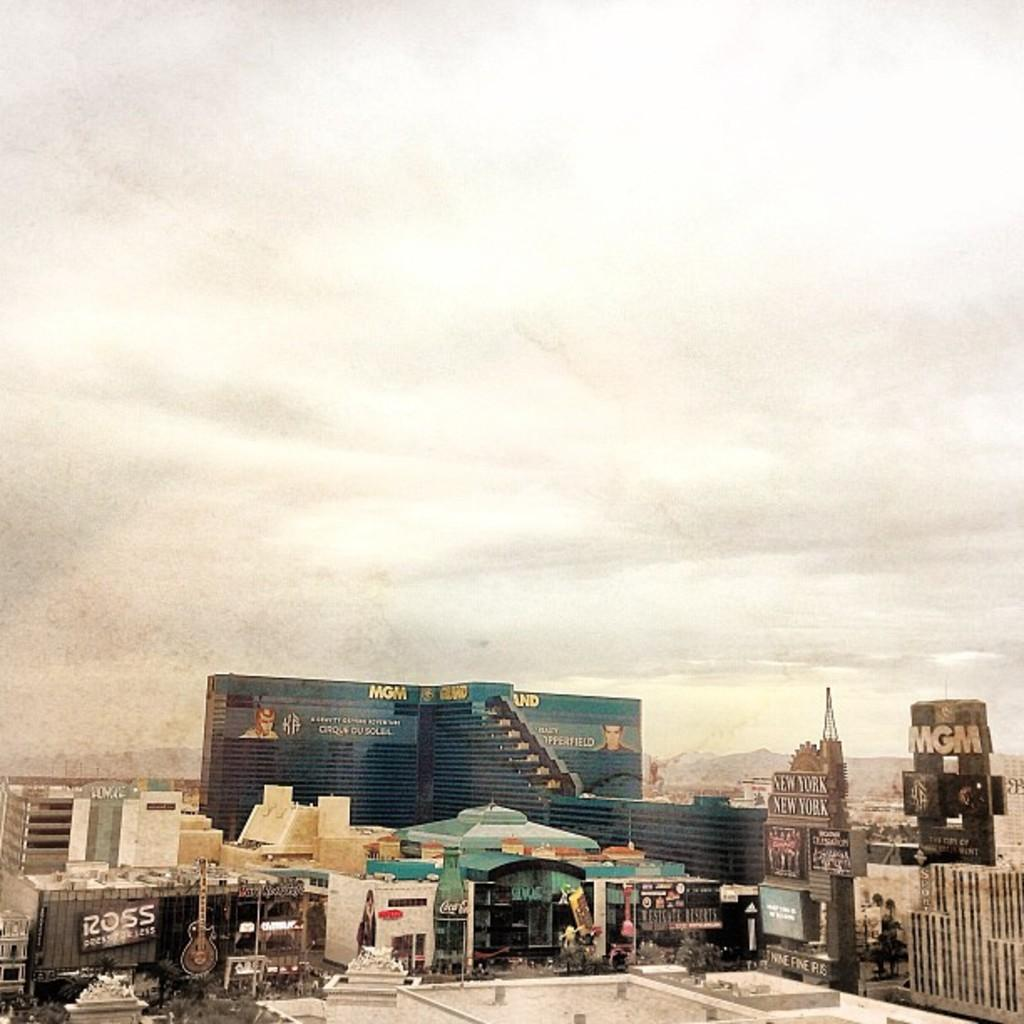What type of structures can be seen in the image? There are buildings in the image. Are there any signs or advertisements visible on the buildings or nearby? Yes, there are hoardings with text in the image. Is there any text directly on the buildings? Yes, there is text on the buildings. How would you describe the weather based on the image? The sky is cloudy in the image. Can you see a goose in motion near the coil in the image? There is no goose or coil present in the image. 